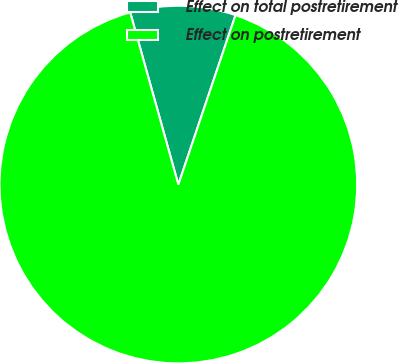Convert chart to OTSL. <chart><loc_0><loc_0><loc_500><loc_500><pie_chart><fcel>Effect on total postretirement<fcel>Effect on postretirement<nl><fcel>9.52%<fcel>90.48%<nl></chart> 